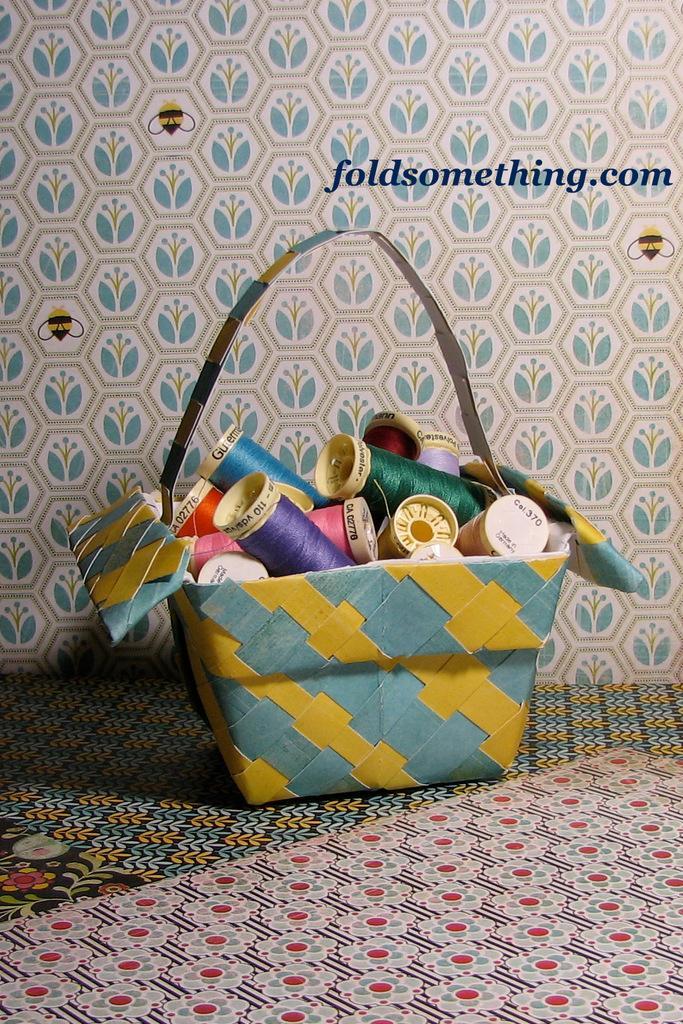In one or two sentences, can you explain what this image depicts? In this image I see a bag in which there lot of threads. In the background I see the wall which is designed very well. 